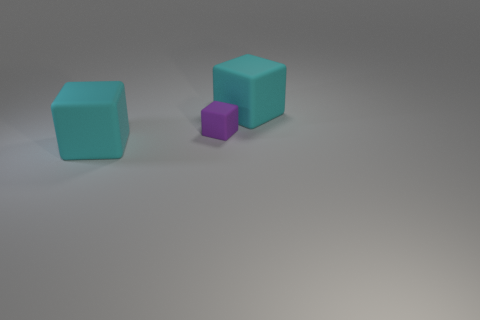Add 1 large objects. How many objects exist? 4 Add 1 purple matte things. How many purple matte things exist? 2 Subtract 0 brown balls. How many objects are left? 3 Subtract all small purple blocks. Subtract all purple matte cubes. How many objects are left? 1 Add 1 cyan rubber cubes. How many cyan rubber cubes are left? 3 